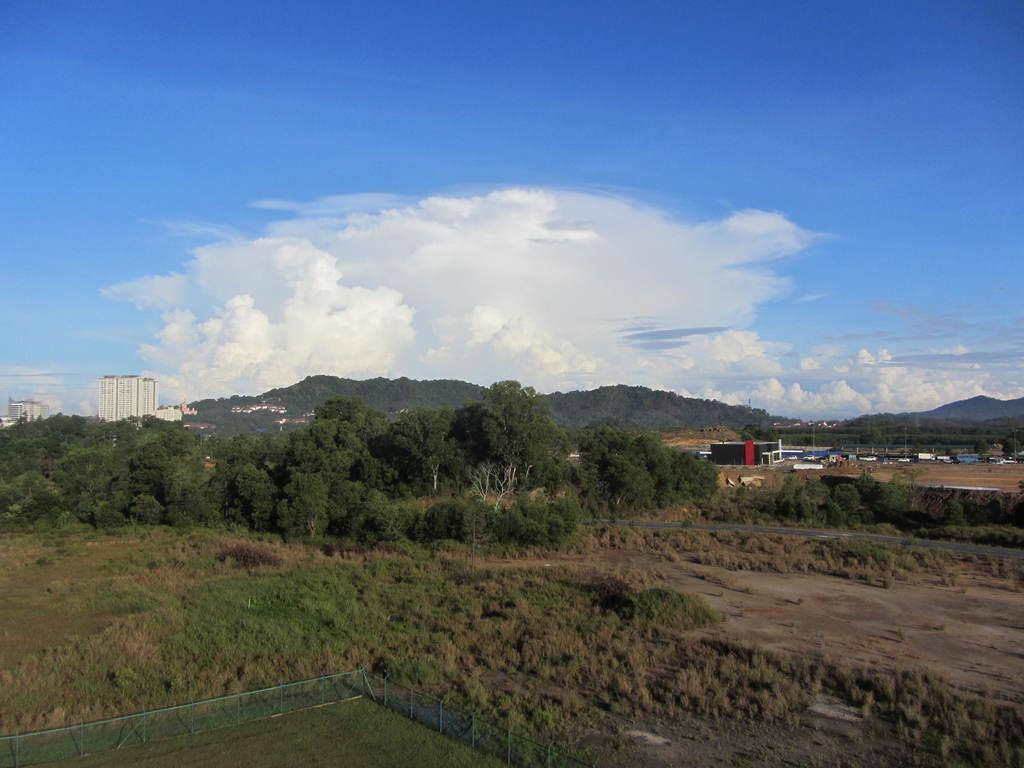Please provide a concise description of this image. In this image there is grass, plants, buildings, trees, hills,sky. 